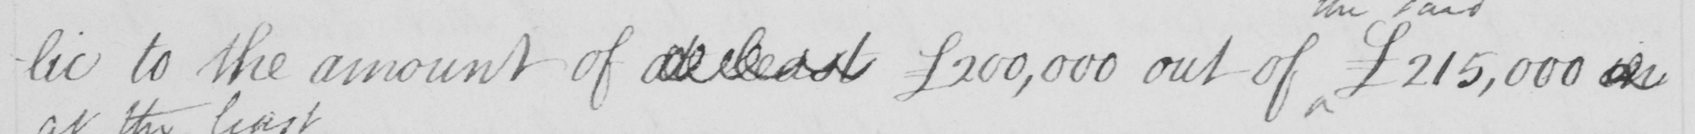Please provide the text content of this handwritten line. -lic to the amount of at least  £200,000 out of  £215,000 in 